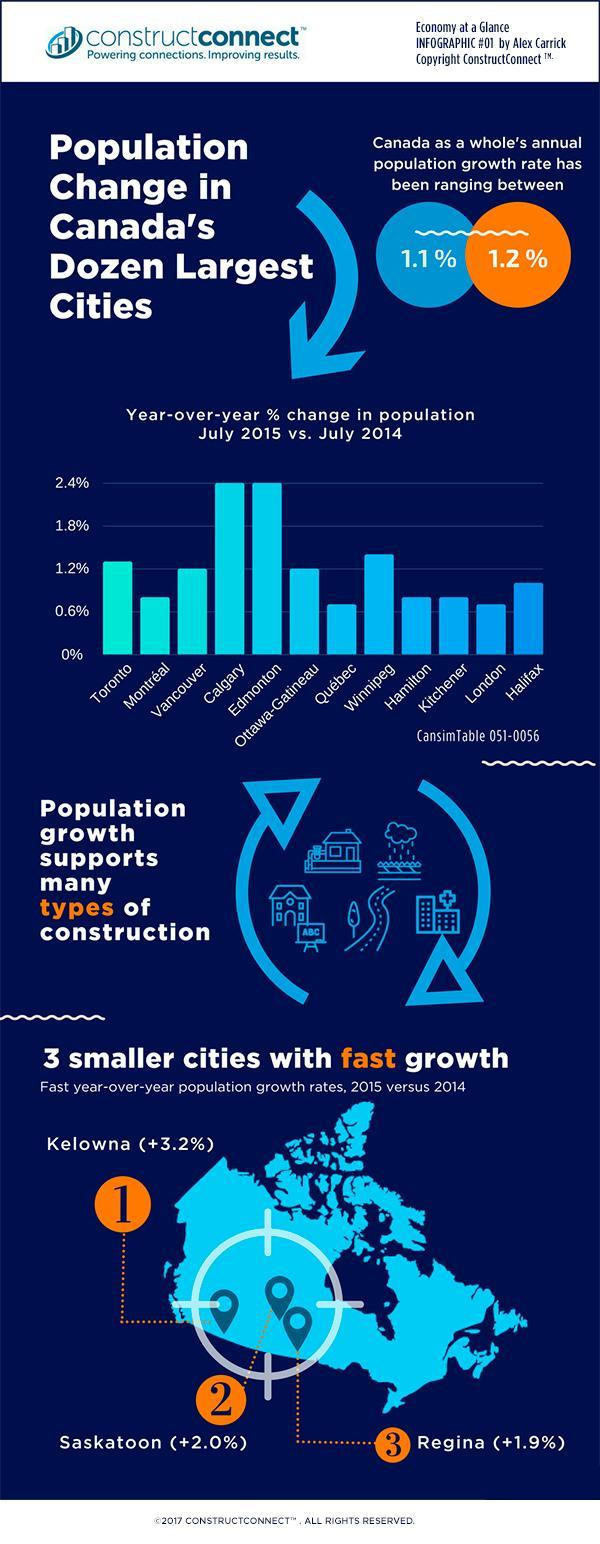Which cities have the smallest percentage change in population?
Answer the question with a short phrase. Quebec, London Which cities have the highest percentage change in population? Calgary, Edmonton Which all are the cities in Canada with fast growth? Kelowna, Saskatoon, Regina 